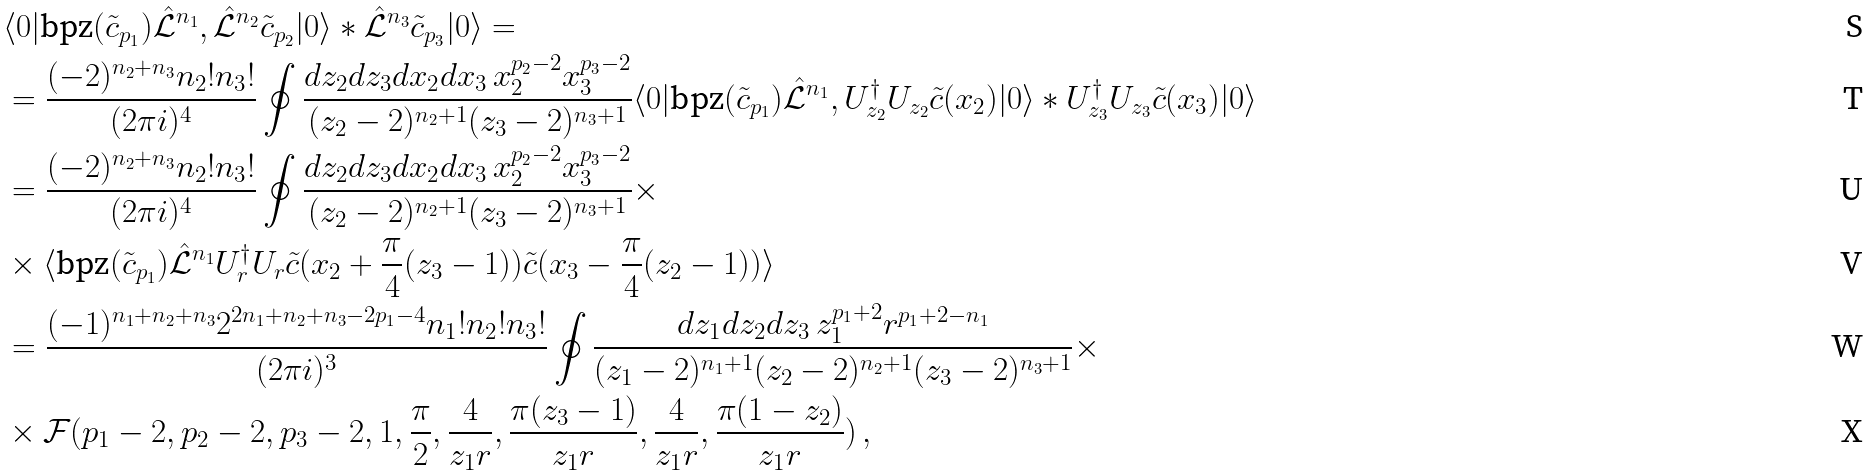<formula> <loc_0><loc_0><loc_500><loc_500>& \langle 0 | \text {bpz} ( \tilde { c } _ { p _ { 1 } } ) \hat { \mathcal { L } } ^ { n _ { 1 } } , \hat { \mathcal { L } } ^ { n _ { 2 } } \tilde { c } _ { p _ { 2 } } | 0 \rangle * \hat { \mathcal { L } } ^ { n _ { 3 } } \tilde { c } _ { p _ { 3 } } | 0 \rangle = \\ & = \frac { ( - 2 ) ^ { n _ { 2 } + n _ { 3 } } n _ { 2 } ! n _ { 3 } ! } { ( 2 \pi i ) ^ { 4 } } \oint \frac { d z _ { 2 } d z _ { 3 } d x _ { 2 } d x _ { 3 } \, x _ { 2 } ^ { p _ { 2 } - 2 } x _ { 3 } ^ { p _ { 3 } - 2 } } { ( z _ { 2 } - 2 ) ^ { n _ { 2 } + 1 } ( z _ { 3 } - 2 ) ^ { n _ { 3 } + 1 } } \langle 0 | \text {bpz} ( \tilde { c } _ { p _ { 1 } } ) \hat { \mathcal { L } } ^ { n _ { 1 } } , U ^ { \dag } _ { z _ { 2 } } U _ { z _ { 2 } } \tilde { c } ( x _ { 2 } ) | 0 \rangle * U ^ { \dag } _ { z _ { 3 } } U _ { z _ { 3 } } \tilde { c } ( x _ { 3 } ) | 0 \rangle \\ & = \frac { ( - 2 ) ^ { n _ { 2 } + n _ { 3 } } n _ { 2 } ! n _ { 3 } ! } { ( 2 \pi i ) ^ { 4 } } \oint \frac { d z _ { 2 } d z _ { 3 } d x _ { 2 } d x _ { 3 } \, x _ { 2 } ^ { p _ { 2 } - 2 } x _ { 3 } ^ { p _ { 3 } - 2 } } { ( z _ { 2 } - 2 ) ^ { n _ { 2 } + 1 } ( z _ { 3 } - 2 ) ^ { n _ { 3 } + 1 } } \times \\ & \times \langle \text {bpz} ( \tilde { c } _ { p _ { 1 } } ) \hat { \mathcal { L } } ^ { n _ { 1 } } U ^ { \dag } _ { r } U _ { r } \tilde { c } ( x _ { 2 } + \frac { \pi } { 4 } ( z _ { 3 } - 1 ) ) \tilde { c } ( x _ { 3 } - \frac { \pi } { 4 } ( z _ { 2 } - 1 ) ) \rangle \\ & = \frac { ( - 1 ) ^ { n _ { 1 } + n _ { 2 } + n _ { 3 } } 2 ^ { 2 n _ { 1 } + n _ { 2 } + n _ { 3 } - 2 p _ { 1 } - 4 } n _ { 1 } ! n _ { 2 } ! n _ { 3 } ! } { ( 2 \pi i ) ^ { 3 } } \oint \frac { d z _ { 1 } d z _ { 2 } d z _ { 3 } \, z _ { 1 } ^ { p _ { 1 } + 2 } r ^ { p _ { 1 } + 2 - n _ { 1 } } } { ( z _ { 1 } - 2 ) ^ { n _ { 1 } + 1 } ( z _ { 2 } - 2 ) ^ { n _ { 2 } + 1 } ( z _ { 3 } - 2 ) ^ { n _ { 3 } + 1 } } \times \\ & \times \mathcal { F } ( p _ { 1 } - 2 , p _ { 2 } - 2 , p _ { 3 } - 2 , 1 , \frac { \pi } { 2 } , \frac { 4 } { z _ { 1 } r } , \frac { \pi ( z _ { 3 } - 1 ) } { z _ { 1 } r } , \frac { 4 } { z _ { 1 } r } , \frac { \pi ( 1 - z _ { 2 } ) } { z _ { 1 } r } ) \, ,</formula> 